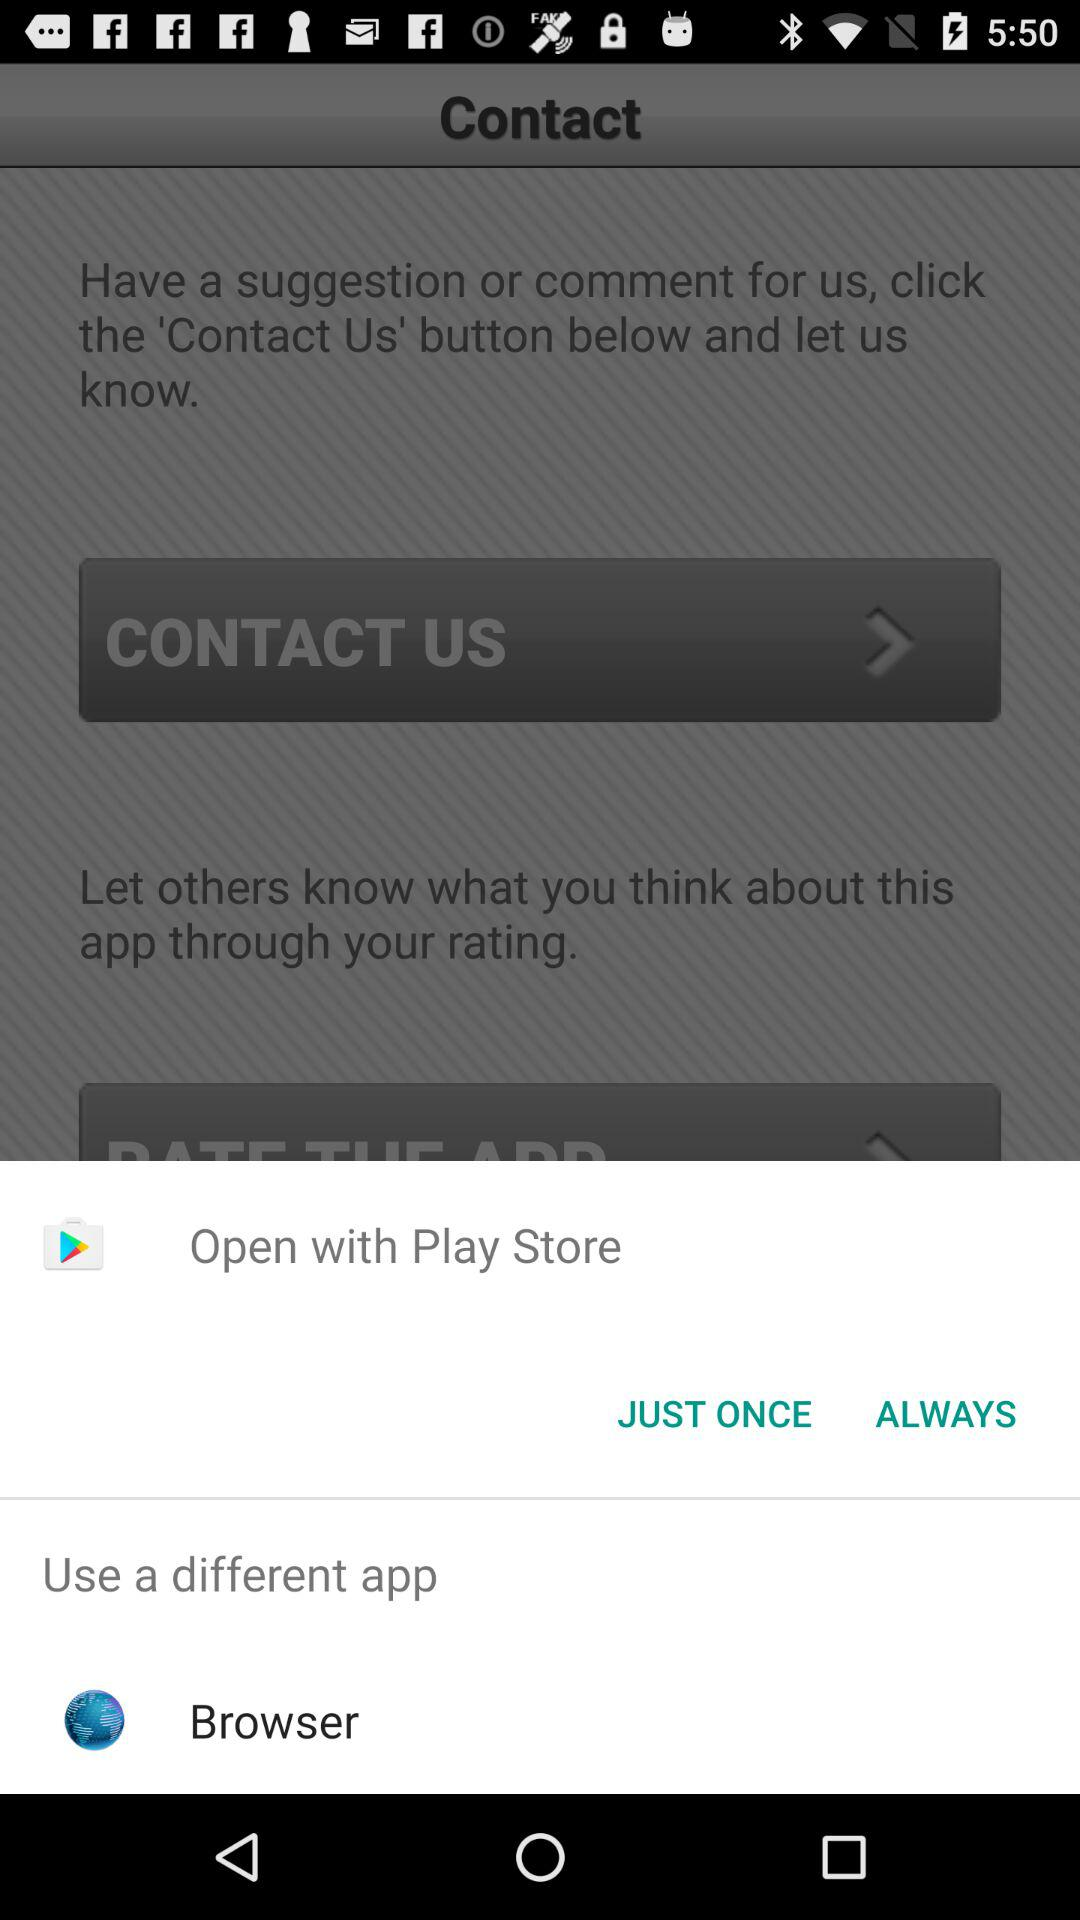Which different app can I use to open it? You can use "Browser" to open. 